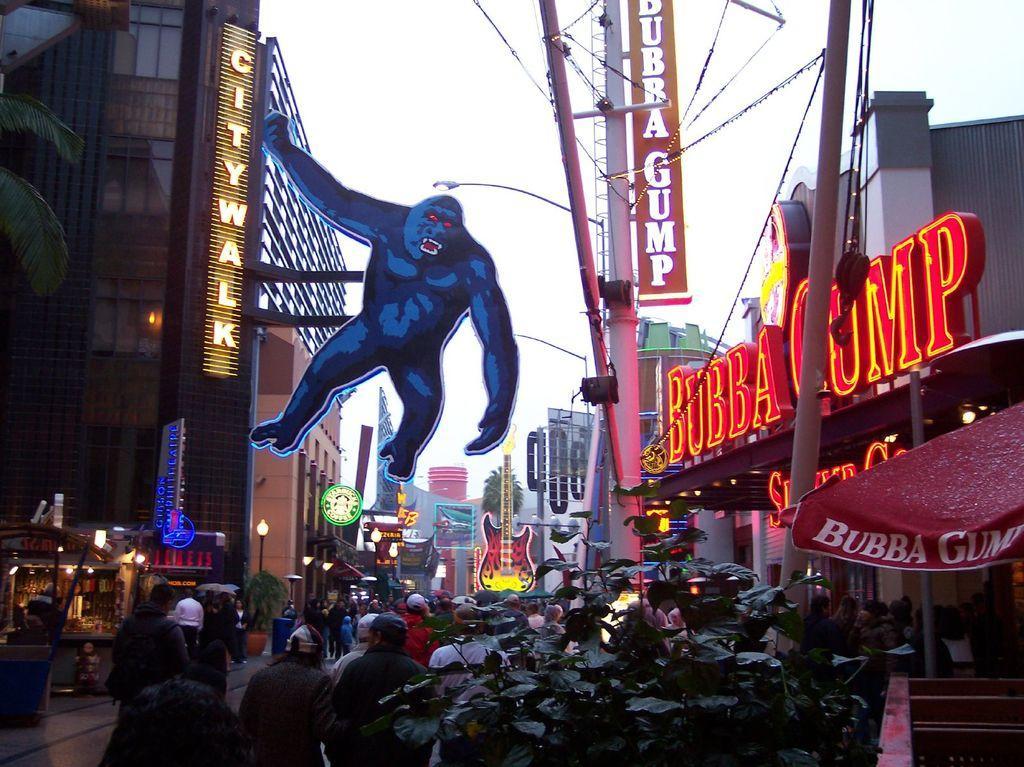Can you describe this image briefly? It looks like a street, there is an image of a gorilla in this. On the right side there are names with lights. At the bottom few people are walking in the streets. 